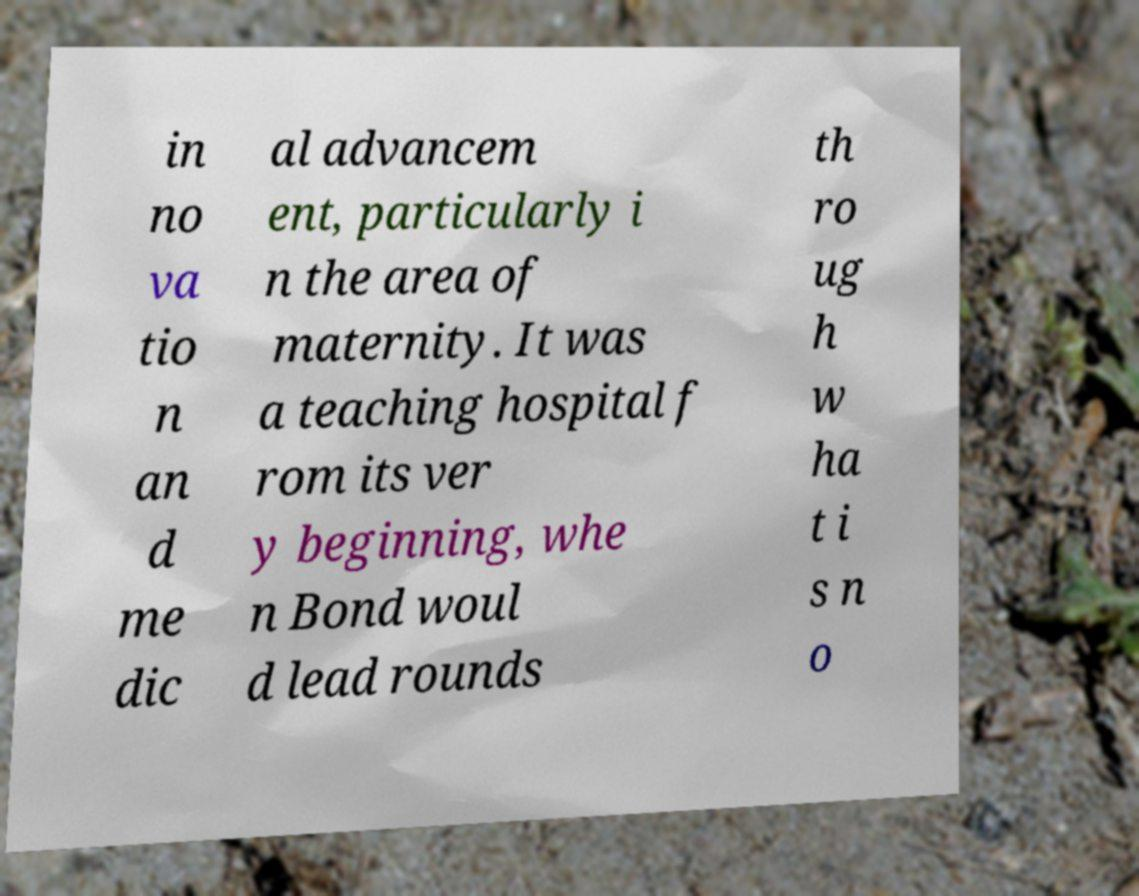There's text embedded in this image that I need extracted. Can you transcribe it verbatim? in no va tio n an d me dic al advancem ent, particularly i n the area of maternity. It was a teaching hospital f rom its ver y beginning, whe n Bond woul d lead rounds th ro ug h w ha t i s n o 